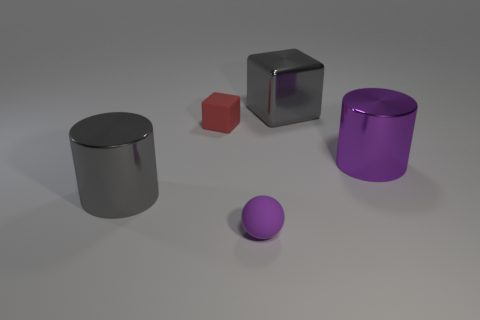Does the small purple rubber object have the same shape as the red rubber thing?
Your answer should be very brief. No. What size is the shiny cylinder to the right of the large gray shiny object behind the big purple thing?
Provide a succinct answer. Large. There is another big thing that is the same shape as the big purple thing; what color is it?
Your answer should be very brief. Gray. How many other tiny rubber cubes have the same color as the tiny rubber block?
Ensure brevity in your answer.  0. How big is the purple metal cylinder?
Keep it short and to the point. Large. Do the matte cube and the sphere have the same size?
Provide a short and direct response. Yes. There is a thing that is both in front of the red block and on the left side of the purple ball; what is its color?
Provide a succinct answer. Gray. What number of purple spheres are the same material as the small purple object?
Keep it short and to the point. 0. How many big yellow matte things are there?
Your answer should be compact. 0. Do the gray cube and the cylinder that is left of the tiny red matte object have the same size?
Offer a very short reply. Yes. 